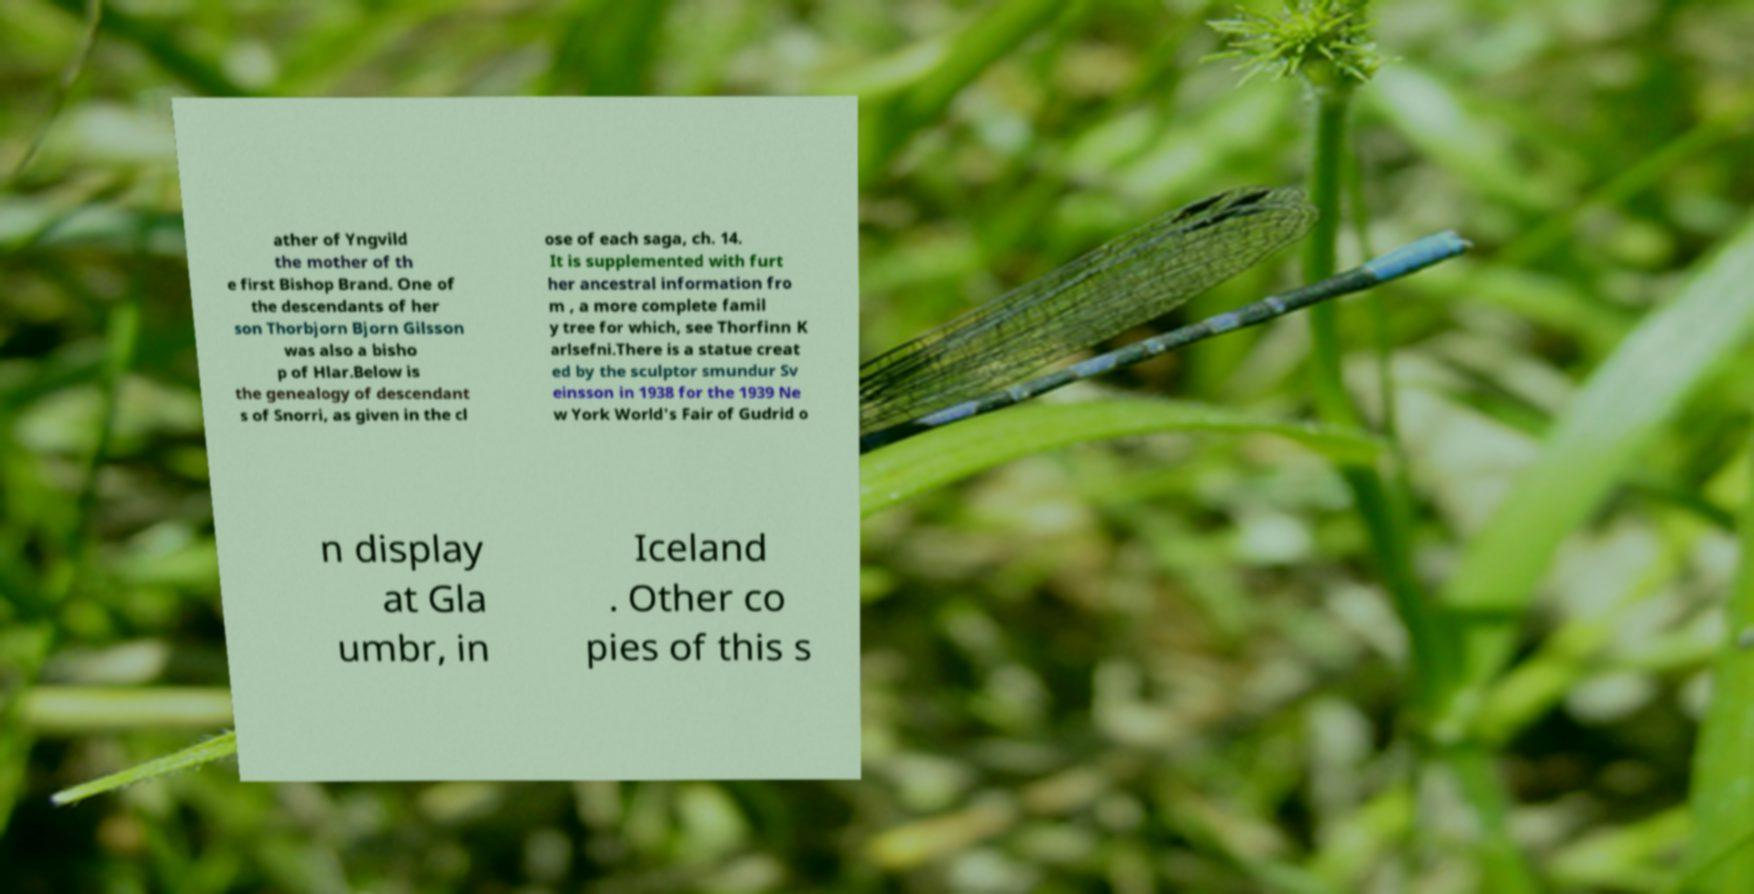Can you read and provide the text displayed in the image?This photo seems to have some interesting text. Can you extract and type it out for me? ather of Yngvild the mother of th e first Bishop Brand. One of the descendants of her son Thorbjorn Bjorn Gilsson was also a bisho p of Hlar.Below is the genealogy of descendant s of Snorri, as given in the cl ose of each saga, ch. 14. It is supplemented with furt her ancestral information fro m , a more complete famil y tree for which, see Thorfinn K arlsefni.There is a statue creat ed by the sculptor smundur Sv einsson in 1938 for the 1939 Ne w York World's Fair of Gudrid o n display at Gla umbr, in Iceland . Other co pies of this s 